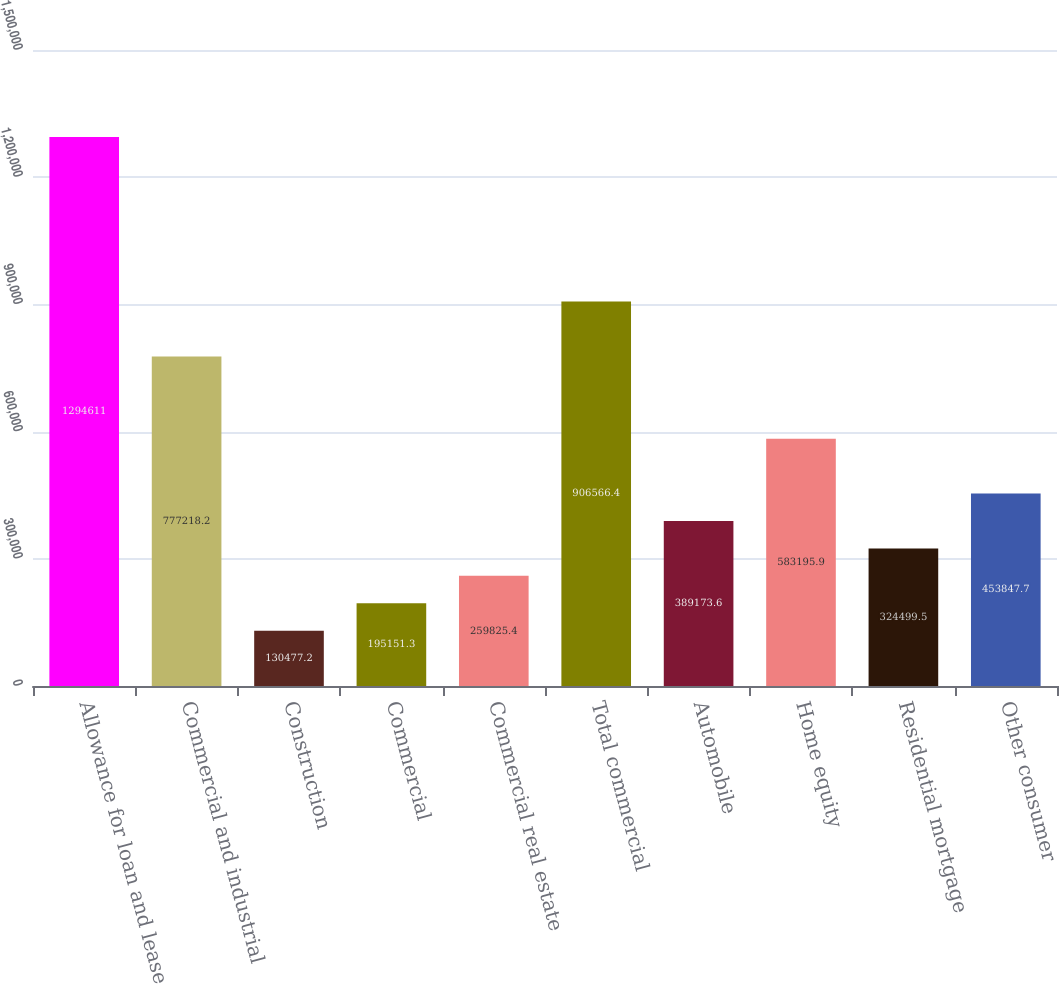<chart> <loc_0><loc_0><loc_500><loc_500><bar_chart><fcel>Allowance for loan and lease<fcel>Commercial and industrial<fcel>Construction<fcel>Commercial<fcel>Commercial real estate<fcel>Total commercial<fcel>Automobile<fcel>Home equity<fcel>Residential mortgage<fcel>Other consumer<nl><fcel>1.29461e+06<fcel>777218<fcel>130477<fcel>195151<fcel>259825<fcel>906566<fcel>389174<fcel>583196<fcel>324500<fcel>453848<nl></chart> 